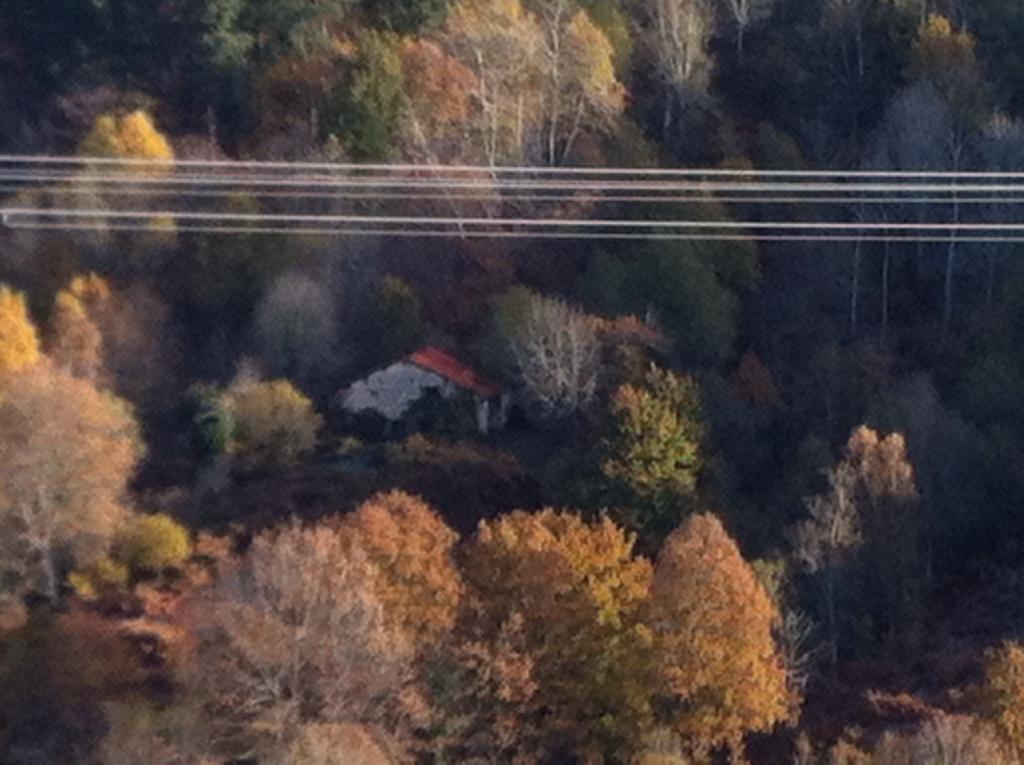What type of vegetation can be seen in the image? There are trees in the image. What type of structure is visible in the image? There is a house in the image. What can be seen running horizontally at the top of the image? There are wires visible from left to right at the top of the image. How many beds are visible in the image? There are no beds present in the image. What type of learning is taking place in the image? There is no learning activity depicted in the image. 